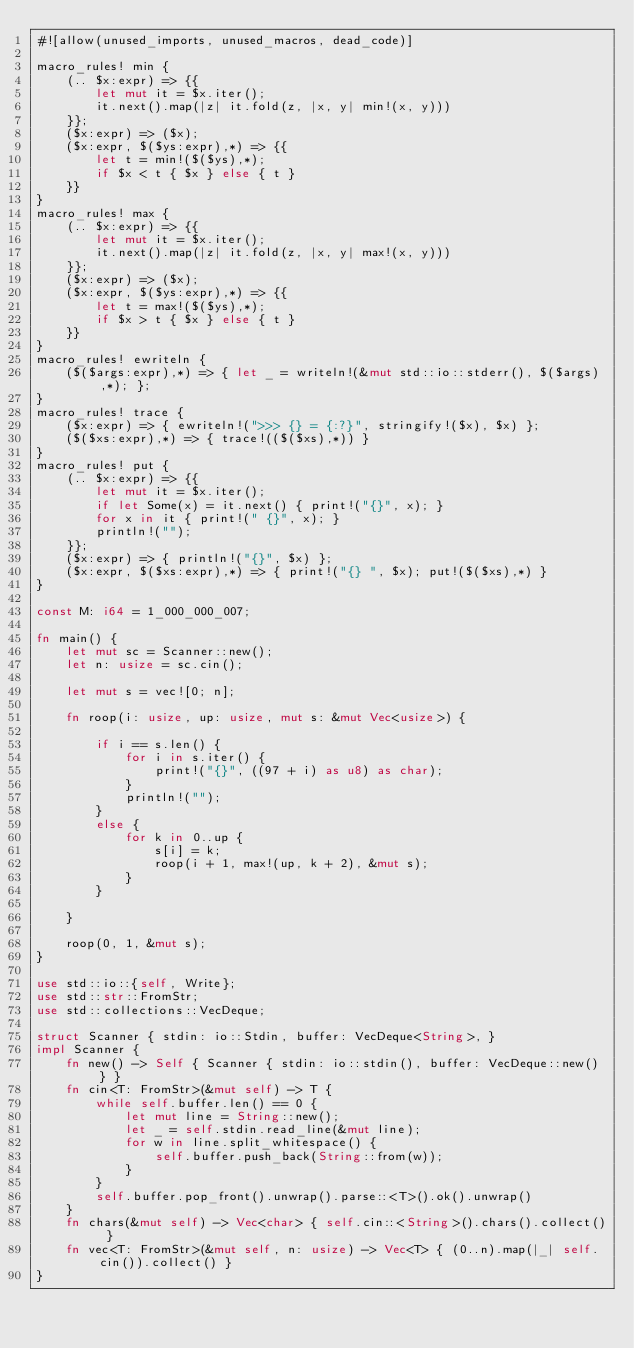Convert code to text. <code><loc_0><loc_0><loc_500><loc_500><_Rust_>#![allow(unused_imports, unused_macros, dead_code)]

macro_rules! min {
    (.. $x:expr) => {{
        let mut it = $x.iter();
        it.next().map(|z| it.fold(z, |x, y| min!(x, y)))
    }};
    ($x:expr) => ($x);
    ($x:expr, $($ys:expr),*) => {{
        let t = min!($($ys),*);
        if $x < t { $x } else { t }
    }}
}
macro_rules! max {
    (.. $x:expr) => {{
        let mut it = $x.iter();
        it.next().map(|z| it.fold(z, |x, y| max!(x, y)))
    }};
    ($x:expr) => ($x);
    ($x:expr, $($ys:expr),*) => {{
        let t = max!($($ys),*);
        if $x > t { $x } else { t }
    }}
}
macro_rules! ewriteln {
    ($($args:expr),*) => { let _ = writeln!(&mut std::io::stderr(), $($args),*); };
}
macro_rules! trace {
    ($x:expr) => { ewriteln!(">>> {} = {:?}", stringify!($x), $x) };
    ($($xs:expr),*) => { trace!(($($xs),*)) }
}
macro_rules! put {
    (.. $x:expr) => {{
        let mut it = $x.iter();
        if let Some(x) = it.next() { print!("{}", x); }
        for x in it { print!(" {}", x); }
        println!("");
    }};
    ($x:expr) => { println!("{}", $x) };
    ($x:expr, $($xs:expr),*) => { print!("{} ", $x); put!($($xs),*) }
}

const M: i64 = 1_000_000_007;

fn main() {
    let mut sc = Scanner::new();
    let n: usize = sc.cin();

    let mut s = vec![0; n];

    fn roop(i: usize, up: usize, mut s: &mut Vec<usize>) {

        if i == s.len() {
            for i in s.iter() {
                print!("{}", ((97 + i) as u8) as char);
            }
            println!("");
        }
        else {
            for k in 0..up {
                s[i] = k;
                roop(i + 1, max!(up, k + 2), &mut s);
            }
        }

    }

    roop(0, 1, &mut s);
}

use std::io::{self, Write};
use std::str::FromStr;
use std::collections::VecDeque;

struct Scanner { stdin: io::Stdin, buffer: VecDeque<String>, }
impl Scanner {
    fn new() -> Self { Scanner { stdin: io::stdin(), buffer: VecDeque::new() } }
    fn cin<T: FromStr>(&mut self) -> T {
        while self.buffer.len() == 0 {
            let mut line = String::new();
            let _ = self.stdin.read_line(&mut line);
            for w in line.split_whitespace() {
                self.buffer.push_back(String::from(w));
            }
        }
        self.buffer.pop_front().unwrap().parse::<T>().ok().unwrap()
    }
    fn chars(&mut self) -> Vec<char> { self.cin::<String>().chars().collect() }
    fn vec<T: FromStr>(&mut self, n: usize) -> Vec<T> { (0..n).map(|_| self.cin()).collect() }
}
</code> 